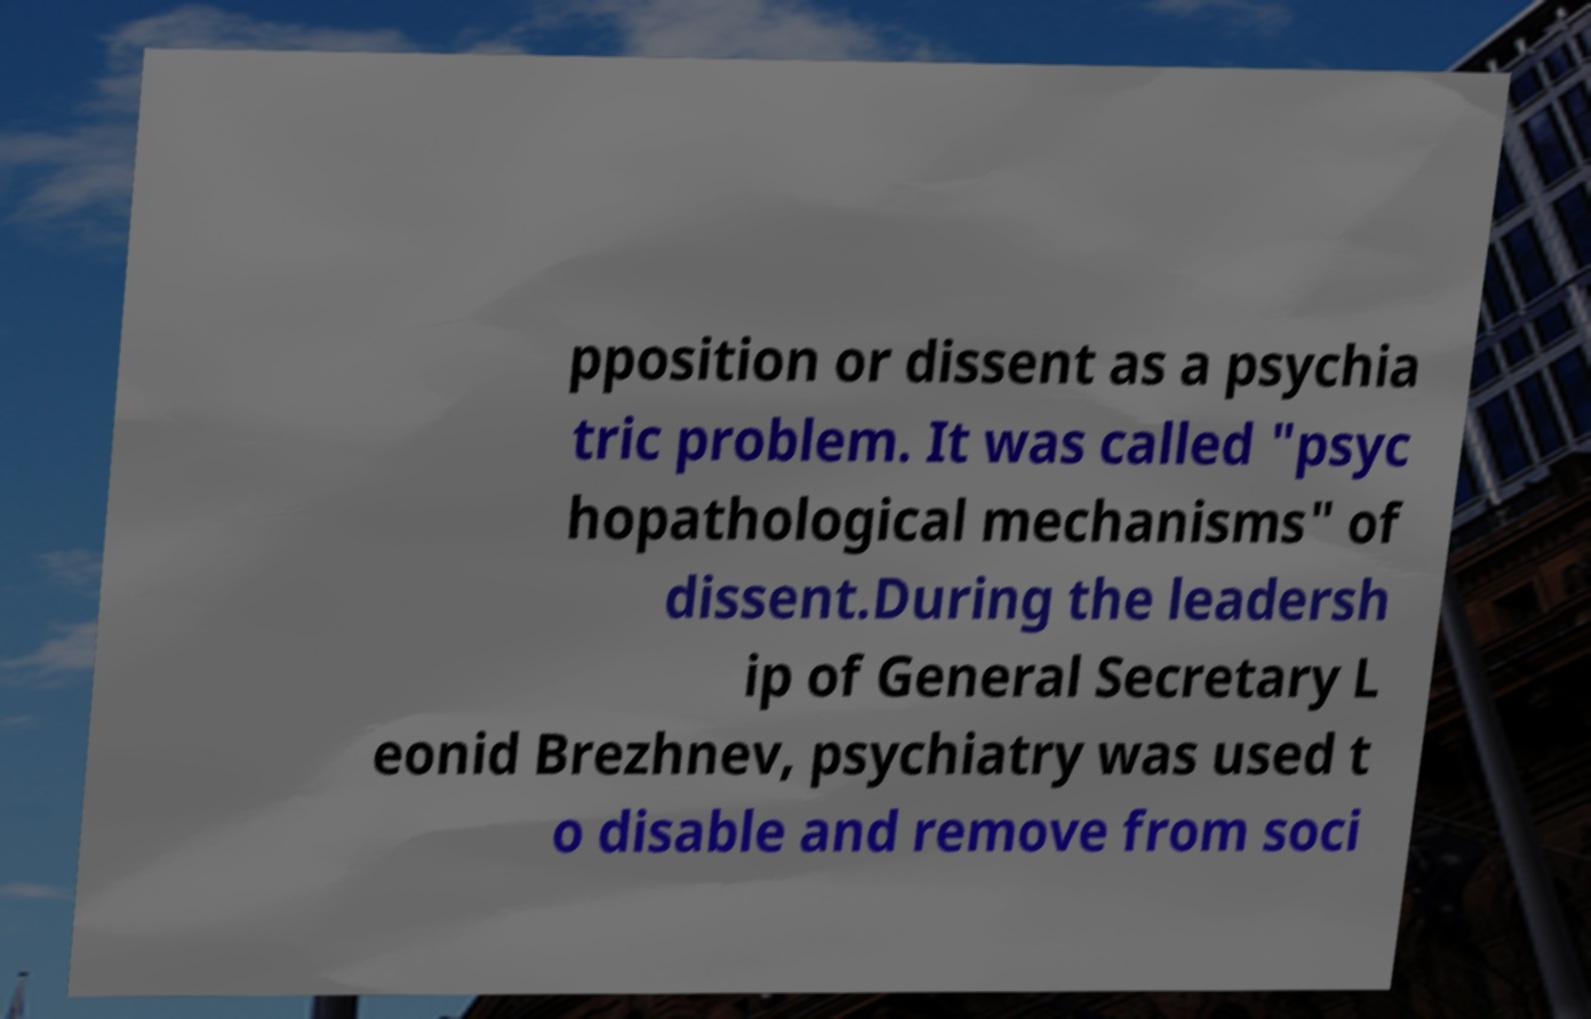Could you assist in decoding the text presented in this image and type it out clearly? pposition or dissent as a psychia tric problem. It was called "psyc hopathological mechanisms" of dissent.During the leadersh ip of General Secretary L eonid Brezhnev, psychiatry was used t o disable and remove from soci 